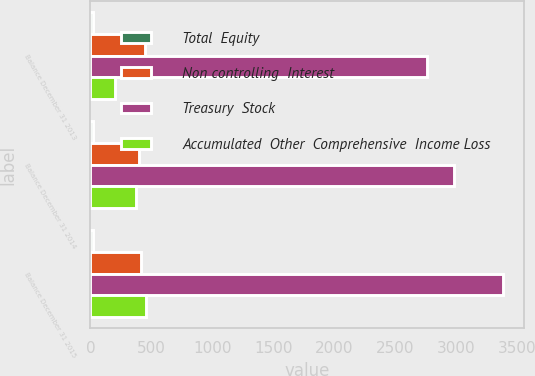Convert chart. <chart><loc_0><loc_0><loc_500><loc_500><stacked_bar_chart><ecel><fcel>Balance December 31 2013<fcel>Balance December 31 2014<fcel>Balance December 31 2015<nl><fcel>Total  Equity<fcel>18.6<fcel>18.6<fcel>18.6<nl><fcel>Non controlling  Interest<fcel>448.3<fcel>401.9<fcel>417.7<nl><fcel>Treasury  Stock<fcel>2757.3<fcel>2984.5<fcel>3385<nl><fcel>Accumulated  Other  Comprehensive  Income Loss<fcel>201.9<fcel>375.8<fcel>457.3<nl></chart> 